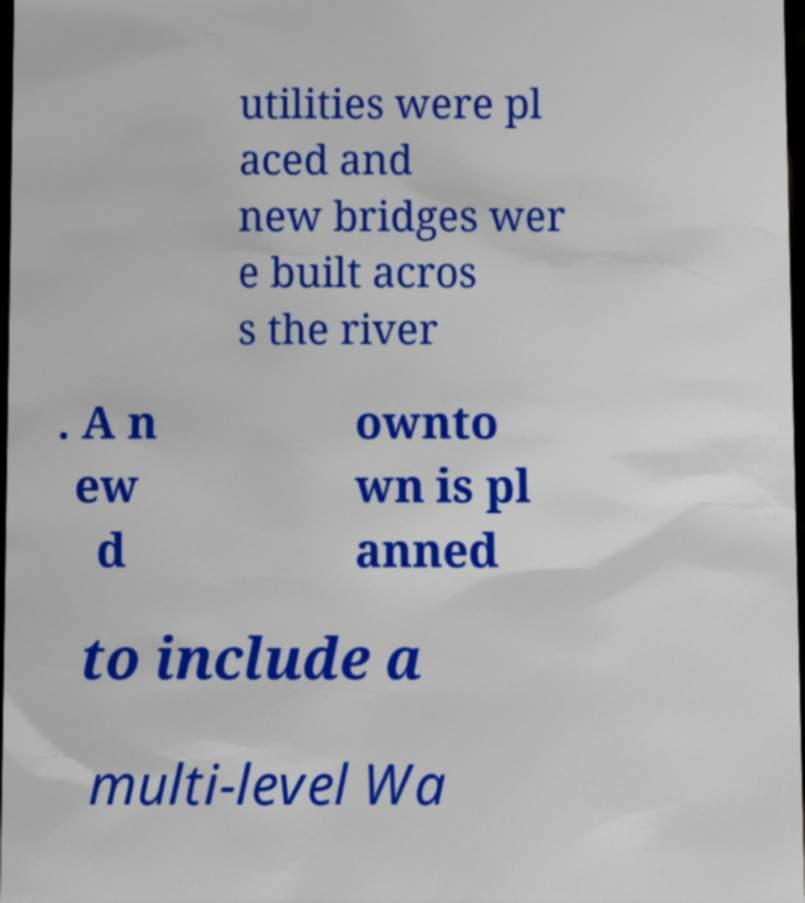For documentation purposes, I need the text within this image transcribed. Could you provide that? utilities were pl aced and new bridges wer e built acros s the river . A n ew d ownto wn is pl anned to include a multi-level Wa 